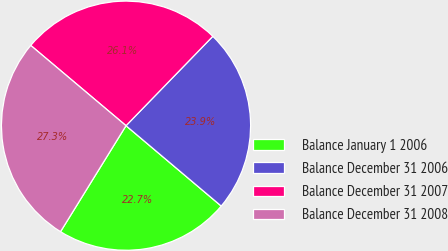Convert chart to OTSL. <chart><loc_0><loc_0><loc_500><loc_500><pie_chart><fcel>Balance January 1 2006<fcel>Balance December 31 2006<fcel>Balance December 31 2007<fcel>Balance December 31 2008<nl><fcel>22.65%<fcel>23.89%<fcel>26.12%<fcel>27.33%<nl></chart> 